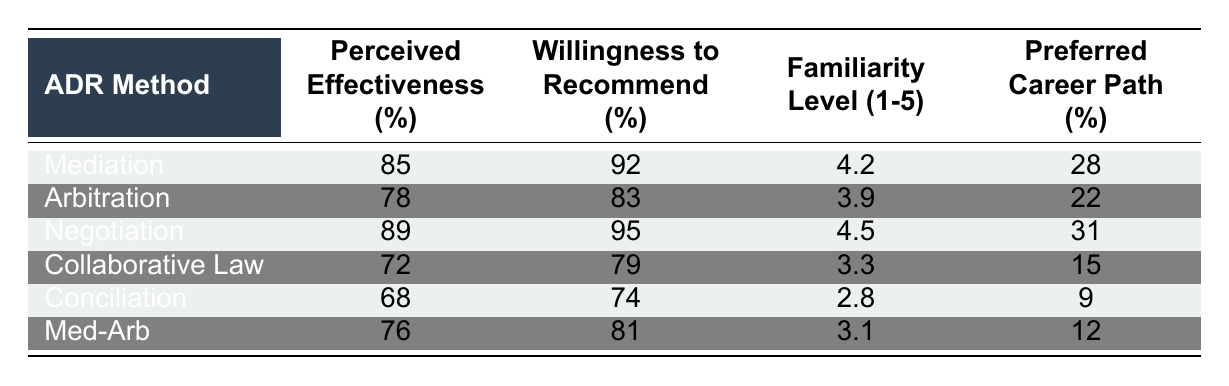What is the perceived effectiveness percentage of Mediation? According to the table, the perceived effectiveness percentage for Mediation is directly listed as 85%.
Answer: 85% Which ADR method has the highest willingness to recommend percentage? The table indicates that Negotiation has the highest willingness to recommend percentage at 95%.
Answer: 95% What is the familiarity level for Collaborative Law? The familiarity level is explicitly stated in the table, where Collaborative Law has a level of 3.3.
Answer: 3.3 Is the willingness to recommend for Conciliation greater than 70%? The table shows that the willingness to recommend for Conciliation is 74%, which is greater than 70%.
Answer: Yes What is the average perceived effectiveness of all ADR methods listed? First, we sum the perceived effectiveness percentages: 85 + 78 + 89 + 72 + 68 + 76 = 468. Then we divide by the number of ADR methods (6): 468 / 6 = 78.
Answer: 78 How does the willingness to recommend for Arbitration compare to that of Med-Arb? Looking at the table, Arbitration has a willingness to recommend of 83%, while Med-Arb has 81%. Since 83% is greater than 81%, Arbitration is recommended more.
Answer: Arbitration is higher What is the overall preferred career path percentage for all listed ADR methods? First, we sum the preferred career path percentages: 28 + 22 + 31 + 15 + 9 + 12 = 117. Then we use the total percentage (100%) divided by the number of ADR methods (6), the average preferred career path is 117 / 6 = 19.5%.
Answer: 19.5% Which ADR method has the lowest familiarity level? By examining the table, Conciliation has the lowest familiarity level, with a score of 2.8, as it is the smallest number listed.
Answer: 2.8 What percentage of students preferred Collaborative Law as a career path? The table indicates that 15% of students preferred Collaborative Law as a career path, as shown next to the respective ADR method.
Answer: 15% Is it true that Mediation's perceived effectiveness is higher than that of Arbitration? The table lists Mediation's perceived effectiveness at 85% and Arbitration's at 78%. Since 85% is greater than 78%, the statement is true.
Answer: Yes Which ADR method has both the highest perceived effectiveness and familiarity level? By analyzing the table, Negotiation has the highest perceived effectiveness (89%) and also a familiarity level of 4.5, which is higher than other methods.
Answer: Negotiation 